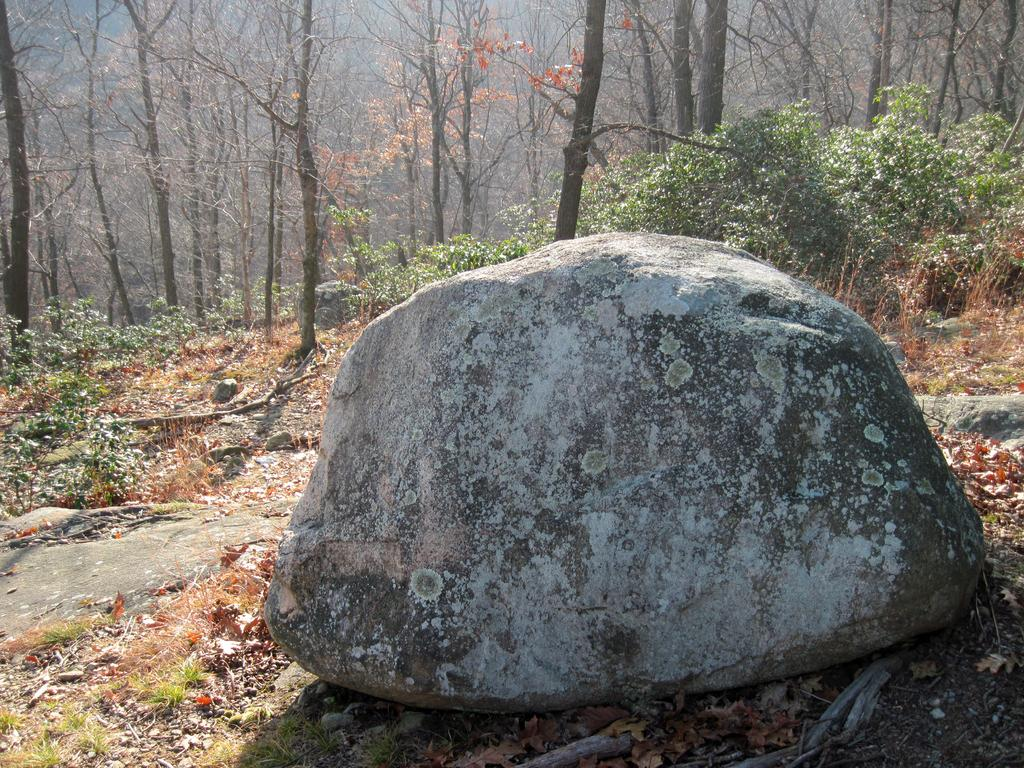What is the main object in the middle of the image? There is a stone in the middle of the image. What can be seen in the background of the image? There are trees and plants in the background of the image. What type of terrain is visible at the bottom of the image? There is land at the bottom of the image. What other objects are present on the land? There are stones, grass, and leaves on the land. What type of riddle can be solved by looking at the stone in the image? There is no riddle present in the image, and therefore no such activity can be observed. Can you see a giraffe in the image? No, there is no giraffe present in the image. 